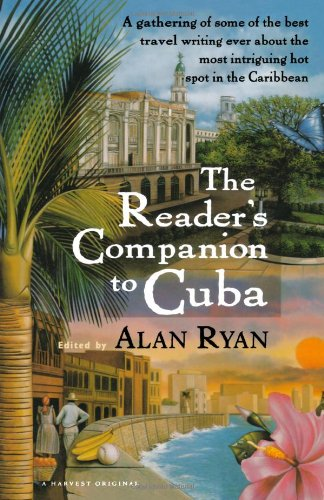Why might the editor of the book be important? The editor, often an expert in the book's subject matter, curates the content to ensure it reflects a comprehensive and authentic perspective. In this case, Alan Ryan brings together compelling narratives about Cuba. 